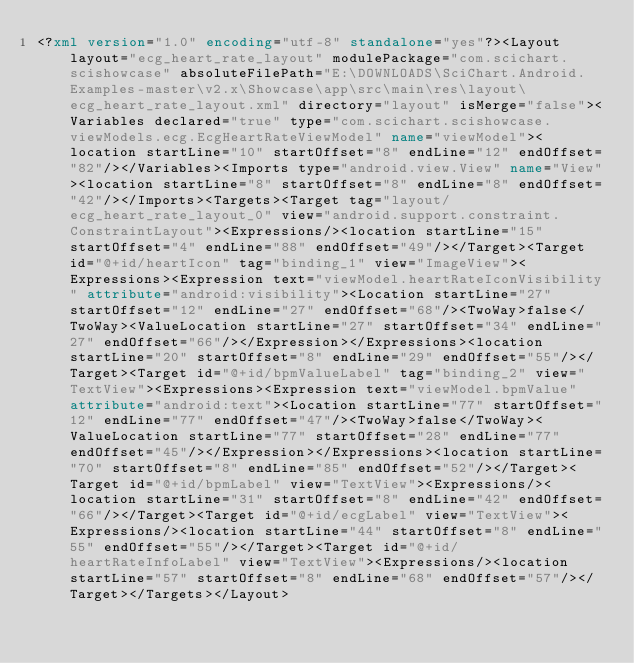<code> <loc_0><loc_0><loc_500><loc_500><_XML_><?xml version="1.0" encoding="utf-8" standalone="yes"?><Layout layout="ecg_heart_rate_layout" modulePackage="com.scichart.scishowcase" absoluteFilePath="E:\DOWNLOADS\SciChart.Android.Examples-master\v2.x\Showcase\app\src\main\res\layout\ecg_heart_rate_layout.xml" directory="layout" isMerge="false"><Variables declared="true" type="com.scichart.scishowcase.viewModels.ecg.EcgHeartRateViewModel" name="viewModel"><location startLine="10" startOffset="8" endLine="12" endOffset="82"/></Variables><Imports type="android.view.View" name="View"><location startLine="8" startOffset="8" endLine="8" endOffset="42"/></Imports><Targets><Target tag="layout/ecg_heart_rate_layout_0" view="android.support.constraint.ConstraintLayout"><Expressions/><location startLine="15" startOffset="4" endLine="88" endOffset="49"/></Target><Target id="@+id/heartIcon" tag="binding_1" view="ImageView"><Expressions><Expression text="viewModel.heartRateIconVisibility" attribute="android:visibility"><Location startLine="27" startOffset="12" endLine="27" endOffset="68"/><TwoWay>false</TwoWay><ValueLocation startLine="27" startOffset="34" endLine="27" endOffset="66"/></Expression></Expressions><location startLine="20" startOffset="8" endLine="29" endOffset="55"/></Target><Target id="@+id/bpmValueLabel" tag="binding_2" view="TextView"><Expressions><Expression text="viewModel.bpmValue" attribute="android:text"><Location startLine="77" startOffset="12" endLine="77" endOffset="47"/><TwoWay>false</TwoWay><ValueLocation startLine="77" startOffset="28" endLine="77" endOffset="45"/></Expression></Expressions><location startLine="70" startOffset="8" endLine="85" endOffset="52"/></Target><Target id="@+id/bpmLabel" view="TextView"><Expressions/><location startLine="31" startOffset="8" endLine="42" endOffset="66"/></Target><Target id="@+id/ecgLabel" view="TextView"><Expressions/><location startLine="44" startOffset="8" endLine="55" endOffset="55"/></Target><Target id="@+id/heartRateInfoLabel" view="TextView"><Expressions/><location startLine="57" startOffset="8" endLine="68" endOffset="57"/></Target></Targets></Layout></code> 